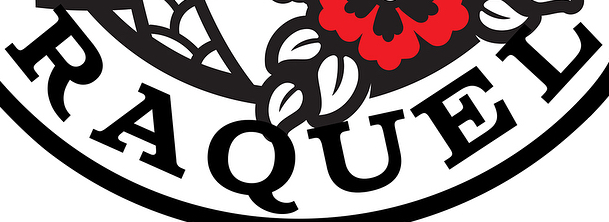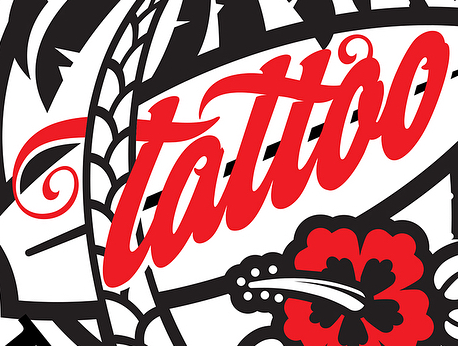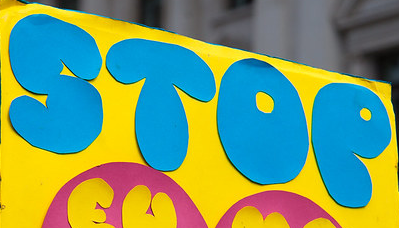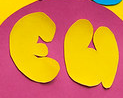Read the text content from these images in order, separated by a semicolon. RAQUEL; tattao; STOP; EU 